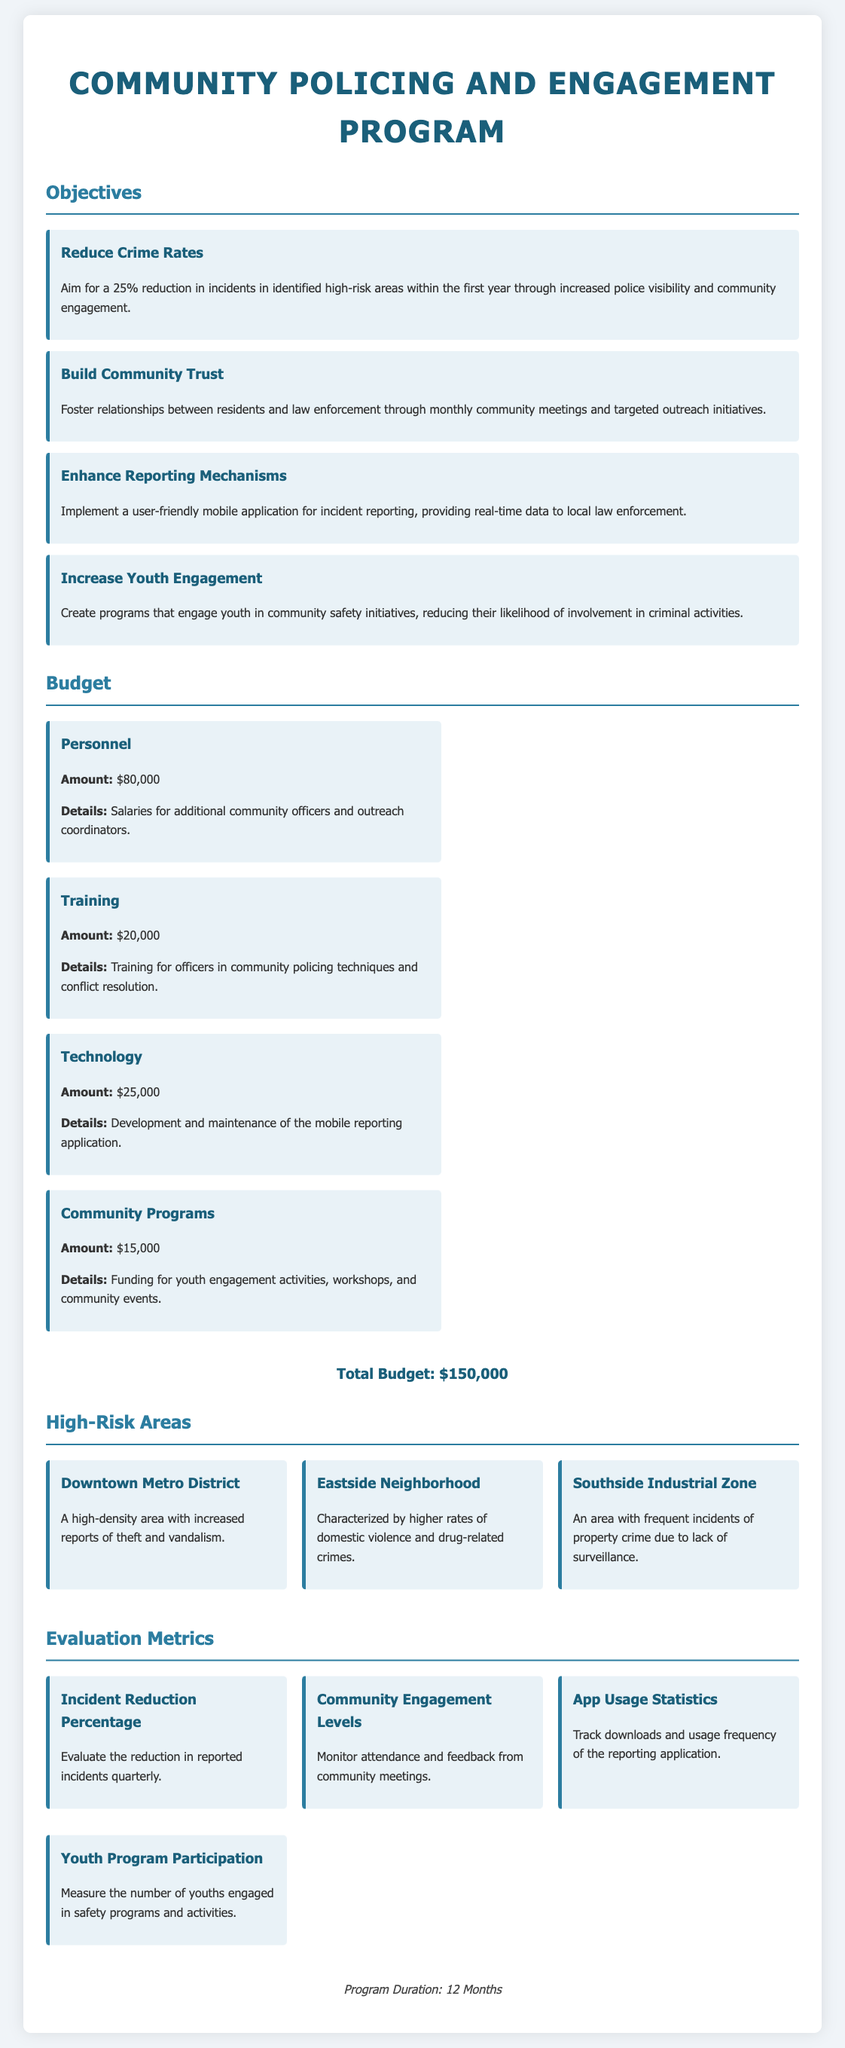What is the title of the program? The title of the program is found at the top of the document under the heading.
Answer: Community Policing and Engagement Program What percentage reduction in incidents is aimed for in the program? The document specifies the percentage reduction targeted within the first year.
Answer: 25% What is the budget allocated for personnel? The exact amount for personnel is detailed in the budget section of the document.
Answer: $80,000 How many high-risk areas are identified in the proposal? The document lists the number of high-risk areas in a dedicated section.
Answer: 3 What type of application will be implemented for reporting incidents? The document describes the nature of the application intended for use in the program.
Answer: Mobile application What is the total budget for the program? The total budget is provided at the end of the budget section.
Answer: $150,000 What is one of the evaluation metrics mentioned in the program? The document outlines metrics used to evaluate the program's effectiveness.
Answer: Incident Reduction Percentage What is the duration of the program? The duration of the program is indicated in the concluding section of the document.
Answer: 12 Months How much funding is allocated for community programs? The specific amount for community programs is listed in the budget breakdown.
Answer: $15,000 What is the primary objective of building community trust? The document mentions the aim associated with fostering relationships with residents.
Answer: Foster relationships between residents and law enforcement 